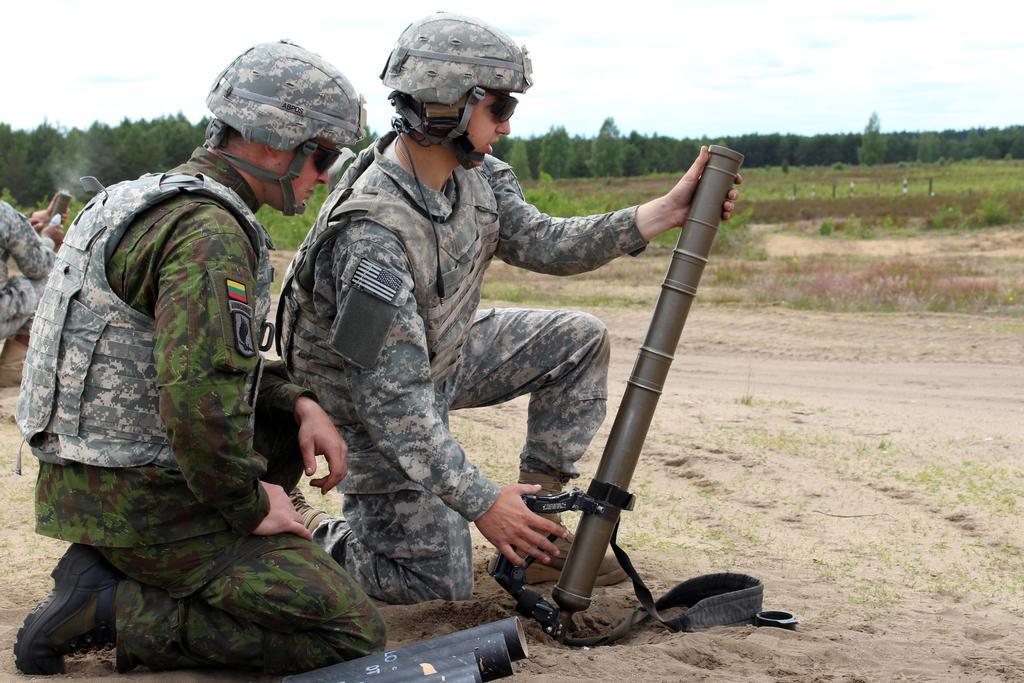In one or two sentences, can you explain what this image depicts? In this image, we can see few people on the ground. Here a person is holding a weapon. At the bottom of the image, we can see few black color objects. Background we can see trees, plants, poles, walkway and sky. 